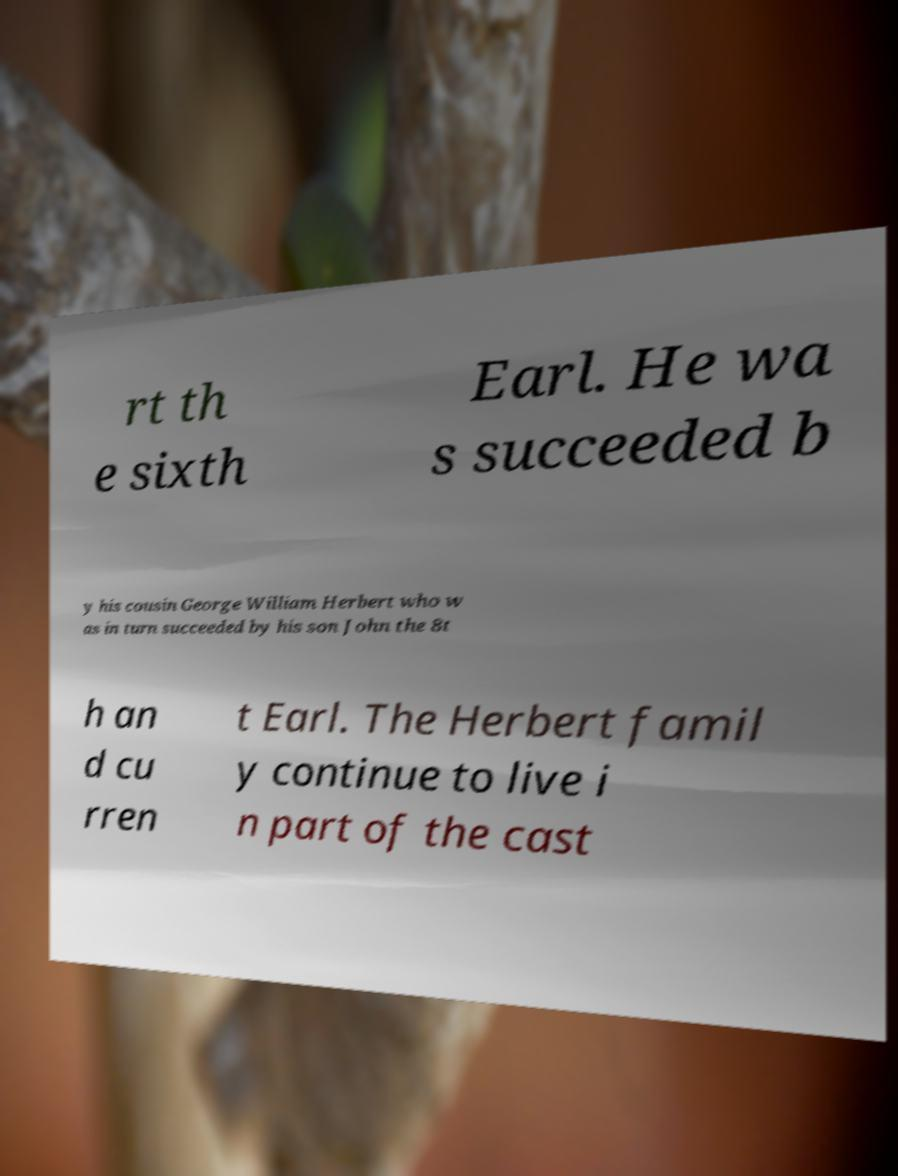What messages or text are displayed in this image? I need them in a readable, typed format. rt th e sixth Earl. He wa s succeeded b y his cousin George William Herbert who w as in turn succeeded by his son John the 8t h an d cu rren t Earl. The Herbert famil y continue to live i n part of the cast 